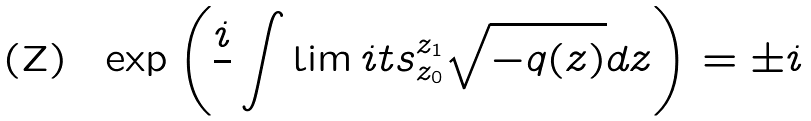Convert formula to latex. <formula><loc_0><loc_0><loc_500><loc_500>\exp \left ( \frac { i } { } \int \lim i t s ^ { z _ { 1 } } _ { z _ { 0 } } \sqrt { - q ( z ) } d z \right ) = \pm i</formula> 